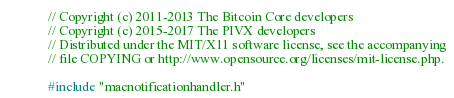<code> <loc_0><loc_0><loc_500><loc_500><_ObjectiveC_>// Copyright (c) 2011-2013 The Bitcoin Core developers
// Copyright (c) 2015-2017 The PIVX developers
// Distributed under the MIT/X11 software license, see the accompanying
// file COPYING or http://www.opensource.org/licenses/mit-license.php.

#include "macnotificationhandler.h"
</code> 